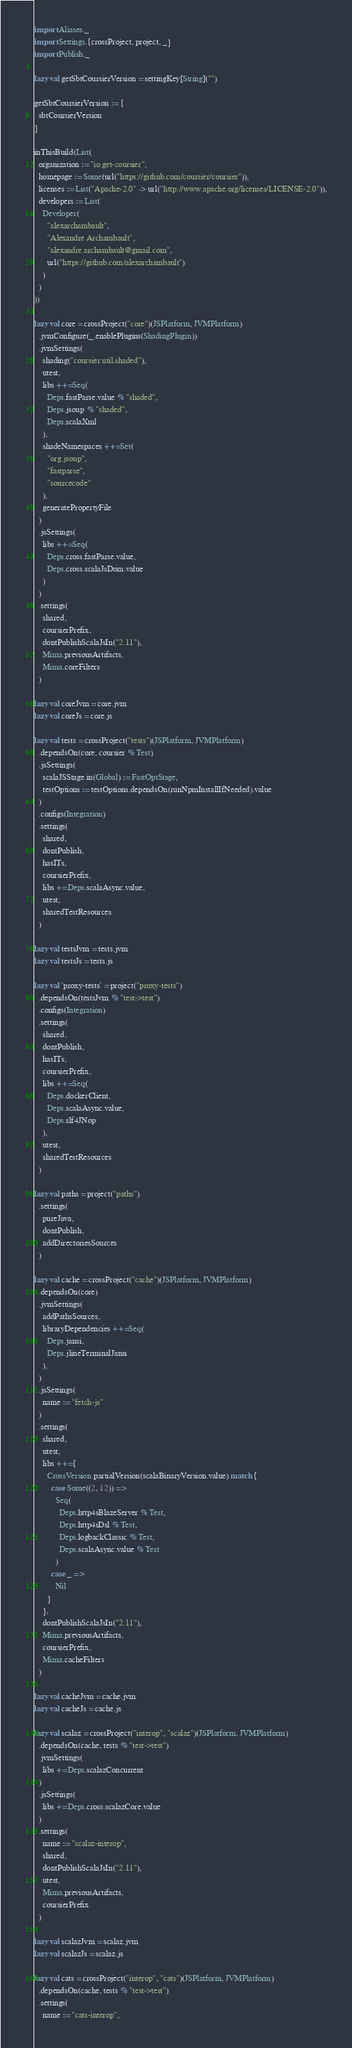Convert code to text. <code><loc_0><loc_0><loc_500><loc_500><_Scala_>
import Aliases._
import Settings.{crossProject, project, _}
import Publish._

lazy val getSbtCoursierVersion = settingKey[String]("")

getSbtCoursierVersion := {
  sbtCoursierVersion
}

inThisBuild(List(
  organization := "io.get-coursier",
  homepage := Some(url("https://github.com/coursier/coursier")),
  licenses := List("Apache-2.0" -> url("http://www.apache.org/licenses/LICENSE-2.0")),
  developers := List(
    Developer(
      "alexarchambault",
      "Alexandre Archambault",
      "alexandre.archambault@gmail.com",
      url("https://github.com/alexarchambault")
    )
  )
))

lazy val core = crossProject("core")(JSPlatform, JVMPlatform)
  .jvmConfigure(_.enablePlugins(ShadingPlugin))
  .jvmSettings(
    shading("coursier.util.shaded"),
    utest,
    libs ++= Seq(
      Deps.fastParse.value % "shaded",
      Deps.jsoup % "shaded",
      Deps.scalaXml
    ),
    shadeNamespaces ++= Set(
      "org.jsoup",
      "fastparse",
      "sourcecode"
    ),
    generatePropertyFile
  )
  .jsSettings(
    libs ++= Seq(
      Deps.cross.fastParse.value,
      Deps.cross.scalaJsDom.value
    )
  )
  .settings(
    shared,
    coursierPrefix,
    dontPublishScalaJsIn("2.11"),
    Mima.previousArtifacts,
    Mima.coreFilters
  )

lazy val coreJvm = core.jvm
lazy val coreJs = core.js

lazy val tests = crossProject("tests")(JSPlatform, JVMPlatform)
  .dependsOn(core, coursier % Test)
  .jsSettings(
    scalaJSStage.in(Global) := FastOptStage,
    testOptions := testOptions.dependsOn(runNpmInstallIfNeeded).value
  )
  .configs(Integration)
  .settings(
    shared,
    dontPublish,
    hasITs,
    coursierPrefix,
    libs += Deps.scalaAsync.value,
    utest,
    sharedTestResources
  )

lazy val testsJvm = tests.jvm
lazy val testsJs = tests.js

lazy val `proxy-tests` = project("proxy-tests")
  .dependsOn(testsJvm % "test->test")
  .configs(Integration)
  .settings(
    shared,
    dontPublish,
    hasITs,
    coursierPrefix,
    libs ++= Seq(
      Deps.dockerClient,
      Deps.scalaAsync.value,
      Deps.slf4JNop
    ),
    utest,
    sharedTestResources
  )

lazy val paths = project("paths")
  .settings(
    pureJava,
    dontPublish,
    addDirectoriesSources
  )

lazy val cache = crossProject("cache")(JSPlatform, JVMPlatform)
  .dependsOn(core)
  .jvmSettings(
    addPathsSources,
    libraryDependencies ++= Seq(
      Deps.jansi,
      Deps.jlineTerminalJansi
    ),
  )
  .jsSettings(
    name := "fetch-js"
  )
  .settings(
    shared,
    utest,
    libs ++= {
      CrossVersion.partialVersion(scalaBinaryVersion.value) match {
        case Some((2, 12)) =>
          Seq(
            Deps.http4sBlazeServer % Test,
            Deps.http4sDsl % Test,
            Deps.logbackClassic % Test,
            Deps.scalaAsync.value % Test
          )
        case _ =>
          Nil
      }
    },
    dontPublishScalaJsIn("2.11"),
    Mima.previousArtifacts,
    coursierPrefix,
    Mima.cacheFilters
  )

lazy val cacheJvm = cache.jvm
lazy val cacheJs = cache.js

lazy val scalaz = crossProject("interop", "scalaz")(JSPlatform, JVMPlatform)
  .dependsOn(cache, tests % "test->test")
  .jvmSettings(
    libs += Deps.scalazConcurrent
  )
  .jsSettings(
    libs += Deps.cross.scalazCore.value
  )
  .settings(
    name := "scalaz-interop",
    shared,
    dontPublishScalaJsIn("2.11"),
    utest,
    Mima.previousArtifacts,
    coursierPrefix
  )

lazy val scalazJvm = scalaz.jvm
lazy val scalazJs = scalaz.js

lazy val cats = crossProject("interop", "cats")(JSPlatform, JVMPlatform)
  .dependsOn(cache, tests % "test->test")
  .settings(
    name := "cats-interop",</code> 